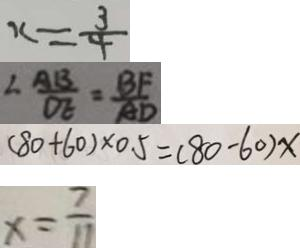<formula> <loc_0><loc_0><loc_500><loc_500>x = \frac { 3 } { 4 } 
 \angle \frac { A B } { O E } = \frac { B F } { A D } 
 ( 8 0 + 6 0 ) \times 0 . 5 = ( 8 0 - 6 0 ) x 
 x = \frac { 7 } { 1 1 }</formula> 